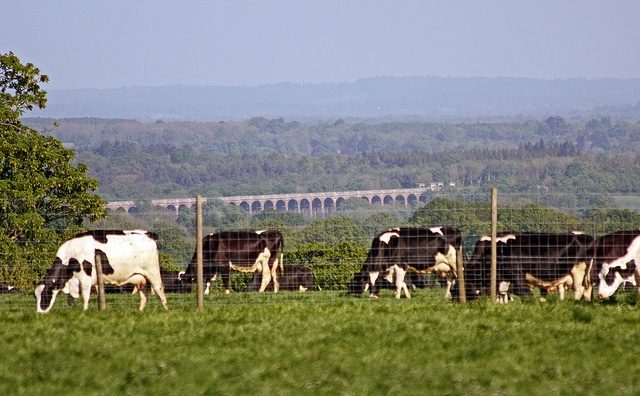Describe the objects in this image and their specific colors. I can see cow in darkgray, black, maroon, gray, and olive tones, cow in darkgray, ivory, black, tan, and maroon tones, cow in darkgray, black, maroon, gray, and beige tones, cow in darkgray, black, maroon, and gray tones, and cow in darkgray, ivory, black, maroon, and brown tones in this image. 